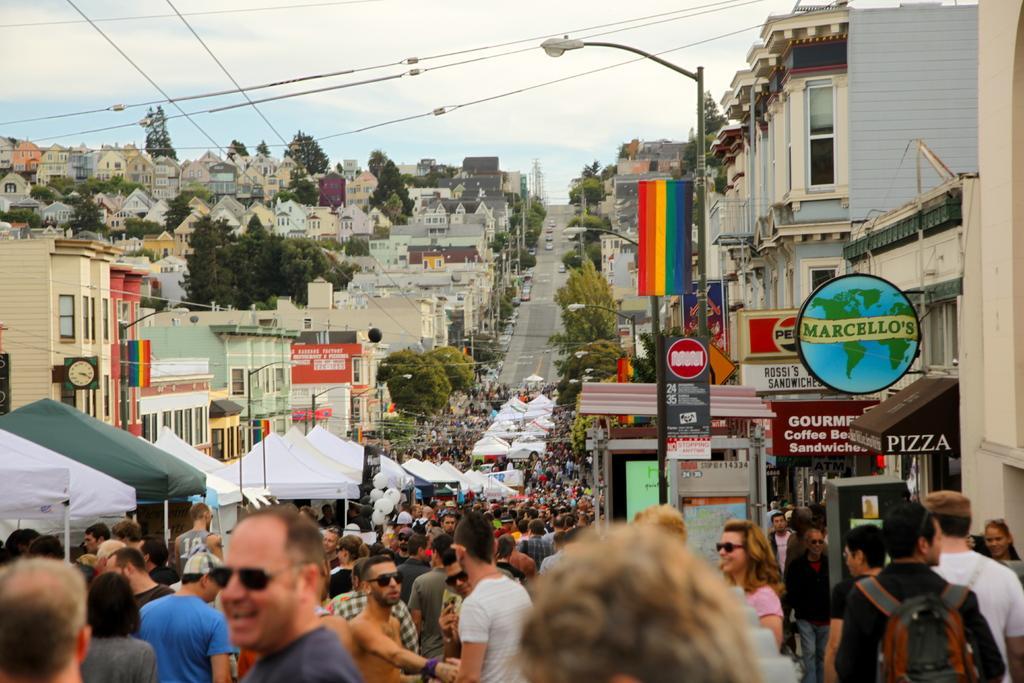Describe this image in one or two sentences. In this image I can see some people. I can see some vehicles on the road. On the left and right side, I can see the houses. At the top I can see clouds in the sky. 